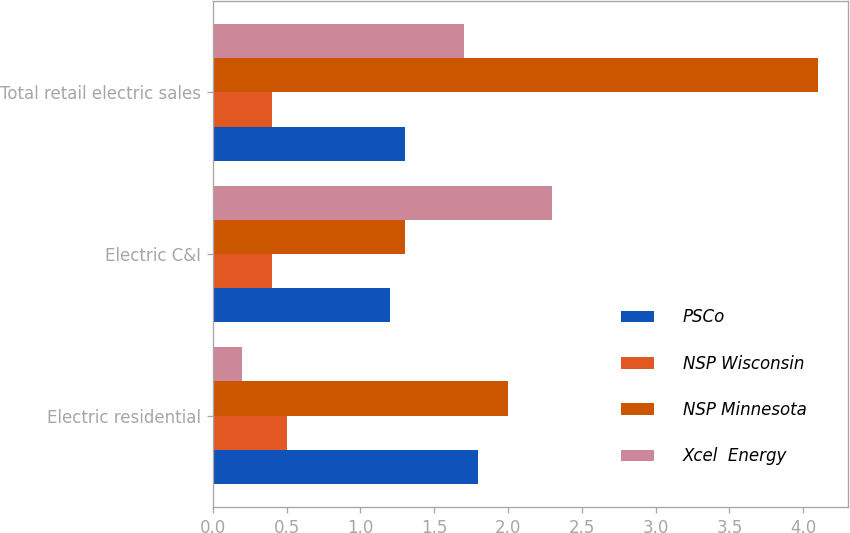<chart> <loc_0><loc_0><loc_500><loc_500><stacked_bar_chart><ecel><fcel>Electric residential<fcel>Electric C&I<fcel>Total retail electric sales<nl><fcel>PSCo<fcel>1.8<fcel>1.2<fcel>1.3<nl><fcel>NSP Wisconsin<fcel>0.5<fcel>0.4<fcel>0.4<nl><fcel>NSP Minnesota<fcel>2<fcel>1.3<fcel>4.1<nl><fcel>Xcel  Energy<fcel>0.2<fcel>2.3<fcel>1.7<nl></chart> 